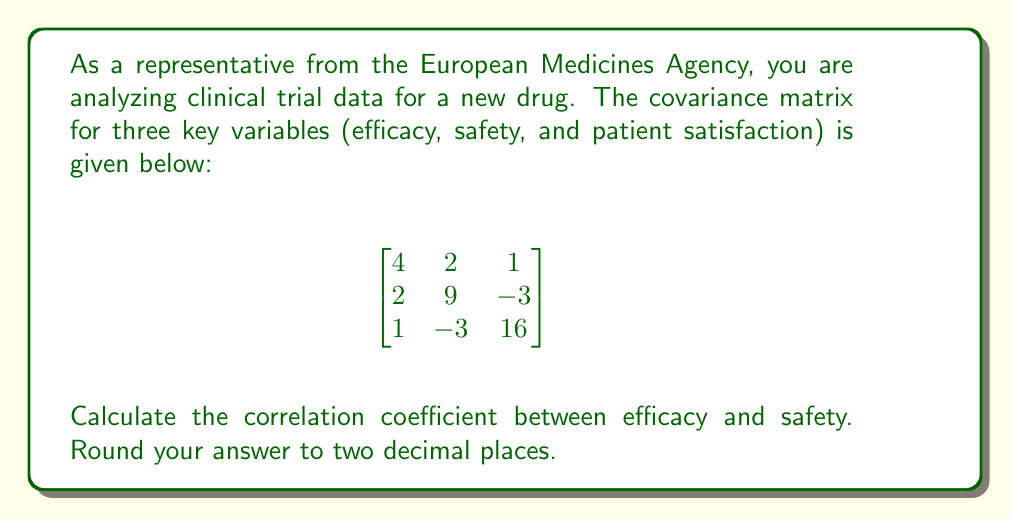Help me with this question. To calculate the correlation coefficient between efficacy and safety, we'll follow these steps:

1) The correlation coefficient is given by the formula:

   $$r_{xy} = \frac{cov(x,y)}{\sigma_x \sigma_y}$$

   where $cov(x,y)$ is the covariance between x and y, and $\sigma_x$ and $\sigma_y$ are the standard deviations of x and y respectively.

2) From the covariance matrix, we can extract:
   - $cov(efficacy, safety) = 2$
   - $var(efficacy) = 4$
   - $var(safety) = 9$

3) The standard deviations are the square roots of the variances:
   - $\sigma_{efficacy} = \sqrt{4} = 2$
   - $\sigma_{safety} = \sqrt{9} = 3$

4) Now we can plug these values into the correlation coefficient formula:

   $$r_{efficacy,safety} = \frac{2}{2 \cdot 3} = \frac{2}{6} = 0.3333...$$

5) Rounding to two decimal places, we get 0.33.
Answer: 0.33 